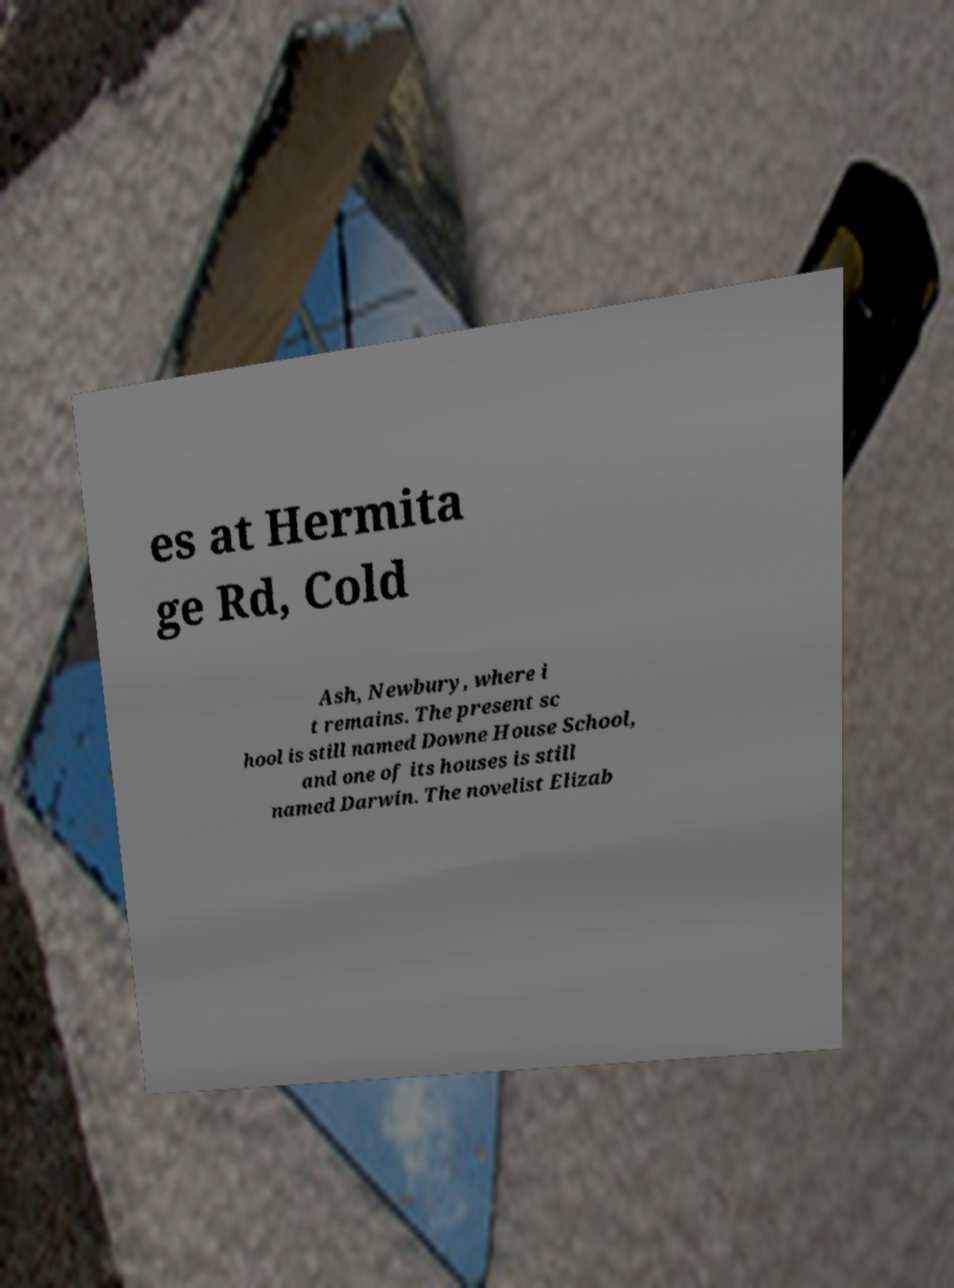I need the written content from this picture converted into text. Can you do that? es at Hermita ge Rd, Cold Ash, Newbury, where i t remains. The present sc hool is still named Downe House School, and one of its houses is still named Darwin. The novelist Elizab 